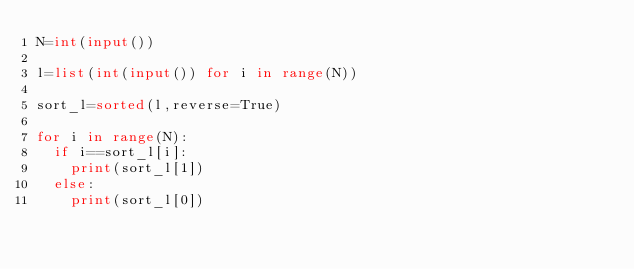<code> <loc_0><loc_0><loc_500><loc_500><_Python_>N=int(input())

l=list(int(input()) for i in range(N))

sort_l=sorted(l,reverse=True)

for i in range(N):
  if i==sort_l[i]:
    print(sort_l[1])
  else:
    print(sort_l[0])</code> 